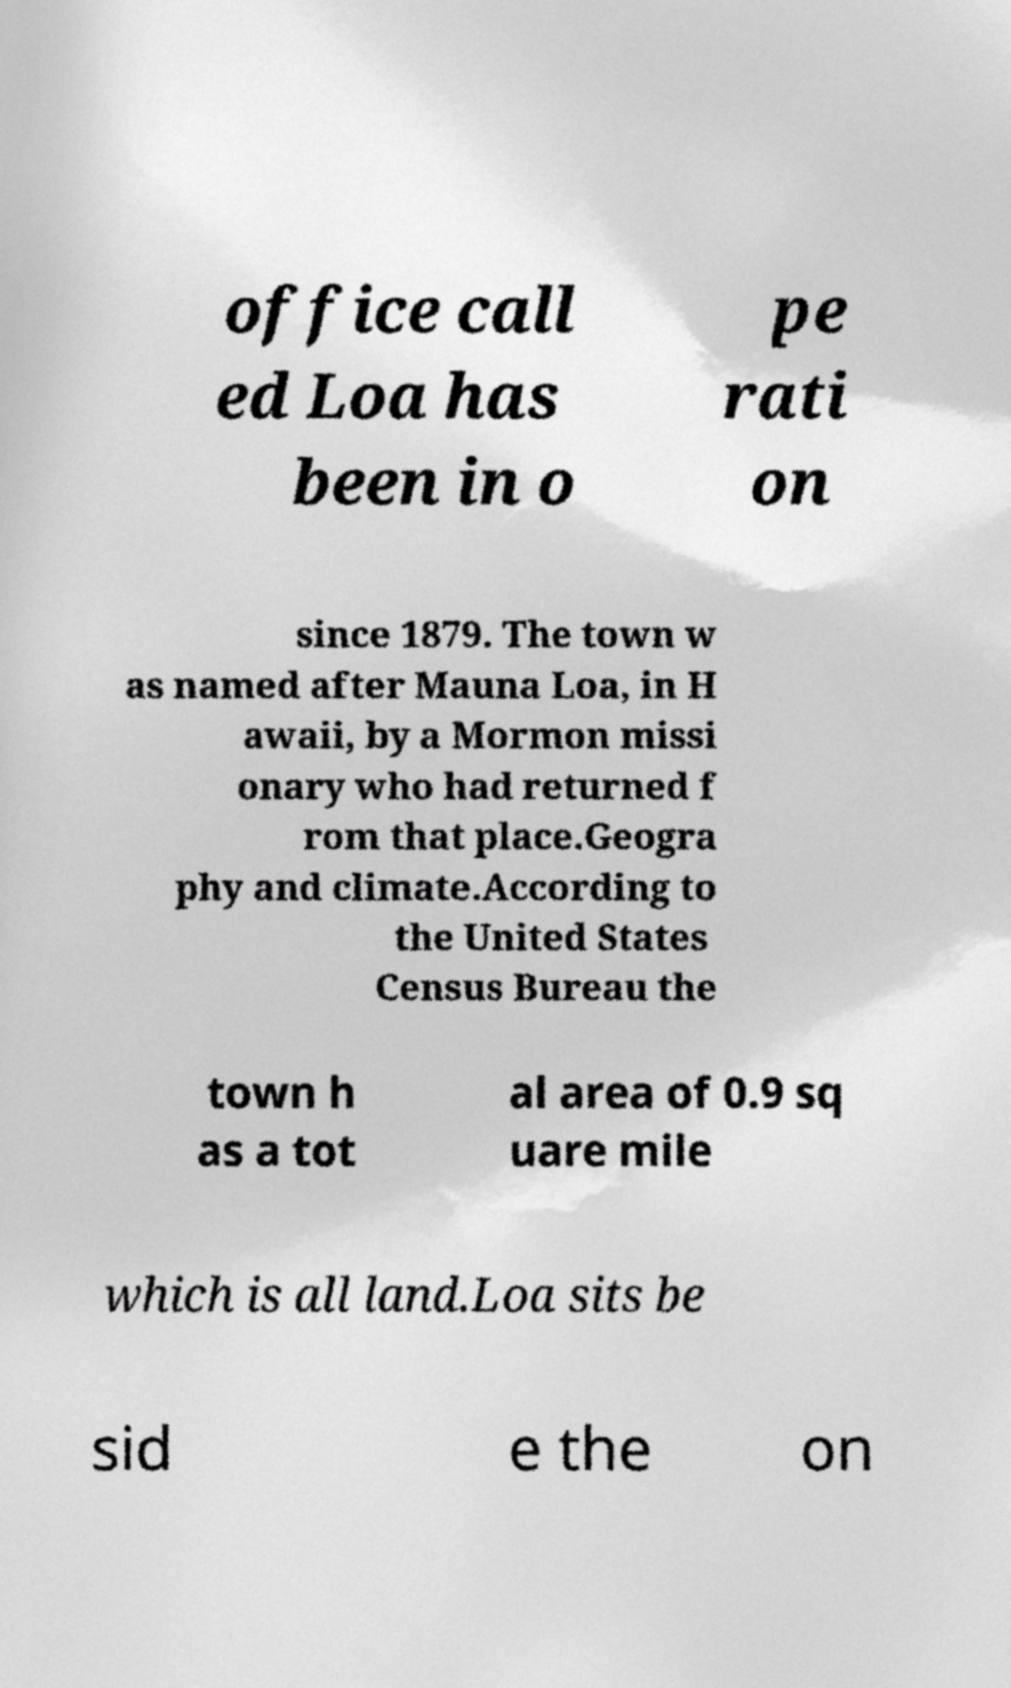I need the written content from this picture converted into text. Can you do that? office call ed Loa has been in o pe rati on since 1879. The town w as named after Mauna Loa, in H awaii, by a Mormon missi onary who had returned f rom that place.Geogra phy and climate.According to the United States Census Bureau the town h as a tot al area of 0.9 sq uare mile which is all land.Loa sits be sid e the on 